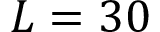Convert formula to latex. <formula><loc_0><loc_0><loc_500><loc_500>L = 3 0</formula> 